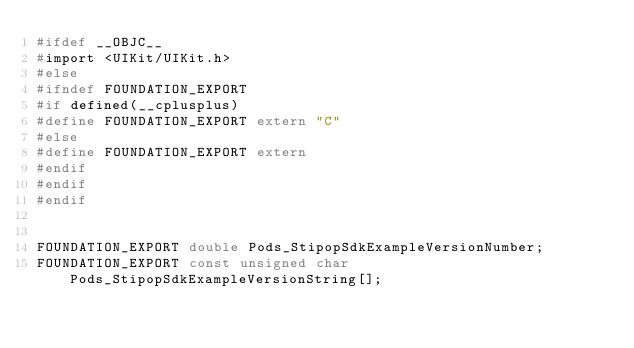Convert code to text. <code><loc_0><loc_0><loc_500><loc_500><_C_>#ifdef __OBJC__
#import <UIKit/UIKit.h>
#else
#ifndef FOUNDATION_EXPORT
#if defined(__cplusplus)
#define FOUNDATION_EXPORT extern "C"
#else
#define FOUNDATION_EXPORT extern
#endif
#endif
#endif


FOUNDATION_EXPORT double Pods_StipopSdkExampleVersionNumber;
FOUNDATION_EXPORT const unsigned char Pods_StipopSdkExampleVersionString[];

</code> 